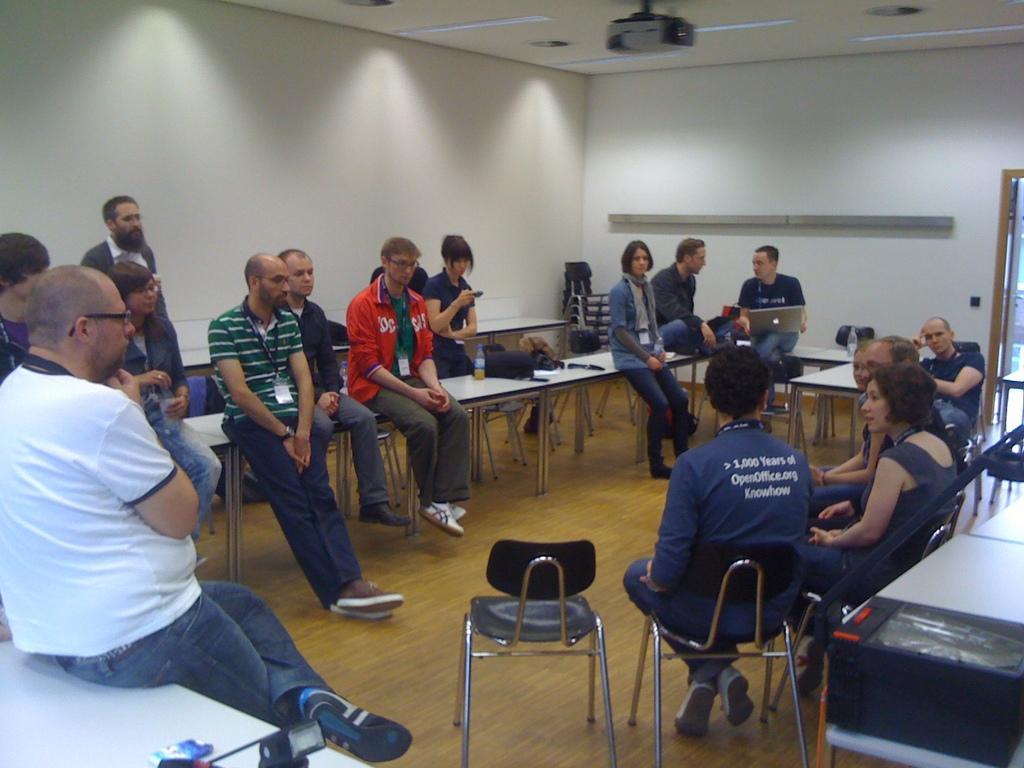Describe this image in one or two sentences. There are group of people sitting on the tables in a room. Some of them are sitting in the chairs. And one guy is holding a laptop. One girl is using a mobile. In the background we can observe a wall here. A projector is connected to the ceiling. 